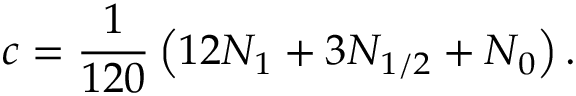<formula> <loc_0><loc_0><loc_500><loc_500>c = \frac { 1 } { 1 2 0 } \left ( 1 2 N _ { 1 } + 3 N _ { 1 / 2 } + N _ { 0 } \right ) .</formula> 